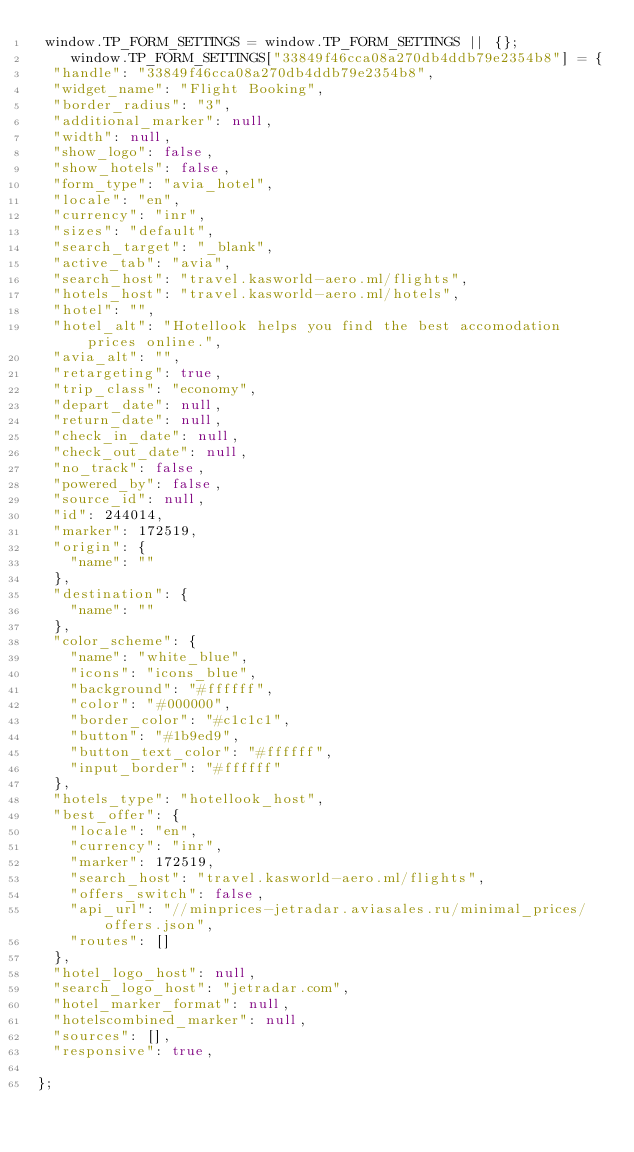<code> <loc_0><loc_0><loc_500><loc_500><_JavaScript_> window.TP_FORM_SETTINGS = window.TP_FORM_SETTINGS || {};
    window.TP_FORM_SETTINGS["33849f46cca08a270db4ddb79e2354b8"] = {
	"handle": "33849f46cca08a270db4ddb79e2354b8",
	"widget_name": "Flight Booking",
	"border_radius": "3",
	"additional_marker": null,
	"width": null,
	"show_logo": false,
	"show_hotels": false,
	"form_type": "avia_hotel",
	"locale": "en",
	"currency": "inr",
	"sizes": "default",
	"search_target": "_blank",
	"active_tab": "avia",
	"search_host": "travel.kasworld-aero.ml/flights",
	"hotels_host": "travel.kasworld-aero.ml/hotels",
	"hotel": "",
	"hotel_alt": "Hotellook helps you find the best accomodation prices online.",
	"avia_alt": "",
	"retargeting": true,
	"trip_class": "economy",
	"depart_date": null,
	"return_date": null,
	"check_in_date": null,
	"check_out_date": null,
	"no_track": false,
	"powered_by": false,
	"source_id": null,
	"id": 244014,
	"marker": 172519,
	"origin": {
		"name": ""
	},
	"destination": {
		"name": ""
	},
	"color_scheme": {
		"name": "white_blue",
		"icons": "icons_blue",
		"background": "#ffffff",
		"color": "#000000",
		"border_color": "#c1c1c1",
		"button": "#1b9ed9",
		"button_text_color": "#ffffff",
		"input_border": "#ffffff"
	},
	"hotels_type": "hotellook_host",
	"best_offer": {
		"locale": "en",
		"currency": "inr",
		"marker": 172519,
		"search_host": "travel.kasworld-aero.ml/flights",
		"offers_switch": false,
		"api_url": "//minprices-jetradar.aviasales.ru/minimal_prices/offers.json",
		"routes": []
	},
	"hotel_logo_host": null,
	"search_logo_host": "jetradar.com",
	"hotel_marker_format": null,
	"hotelscombined_marker": null,
	"sources": [],
	"responsive": true,
	
};
</code> 